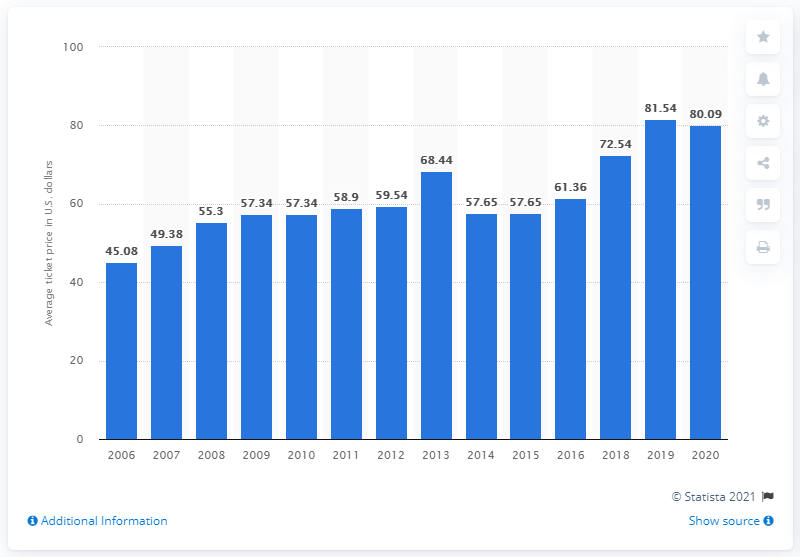Highlight a few significant elements in this photo. The average ticket price for Jacksonville Jaguars games in 2020 was $80.09. 